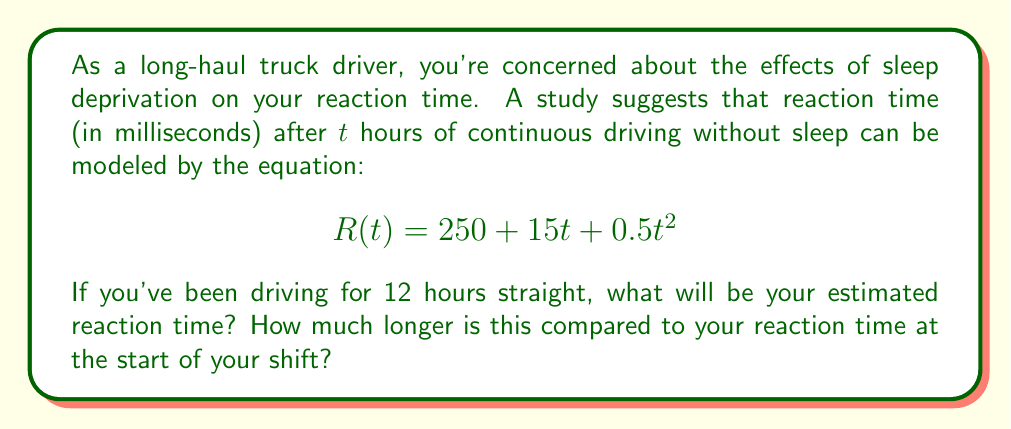What is the answer to this math problem? Let's approach this problem step-by-step:

1) We're given the equation for reaction time $R(t)$ as a function of time $t$ (in hours):
   $$R(t) = 250 + 15t + 0.5t^2$$

2) We need to calculate $R(12)$ to find the reaction time after 12 hours of driving:
   $$R(12) = 250 + 15(12) + 0.5(12)^2$$

3) Let's solve this equation:
   $$R(12) = 250 + 180 + 0.5(144)$$
   $$R(12) = 250 + 180 + 72$$
   $$R(12) = 502$$

4) So, after 12 hours of driving, your estimated reaction time would be 502 milliseconds.

5) To find out how much longer this is compared to the start of your shift, we need to calculate $R(0)$:
   $$R(0) = 250 + 15(0) + 0.5(0)^2 = 250$$

6) The difference in reaction time is:
   $$502 - 250 = 252$$

Therefore, your reaction time after 12 hours of driving is estimated to be 252 milliseconds longer than at the start of your shift.
Answer: Your estimated reaction time after 12 hours of continuous driving would be 502 milliseconds, which is 252 milliseconds longer than at the start of your shift. 